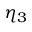<formula> <loc_0><loc_0><loc_500><loc_500>\eta _ { 3 }</formula> 